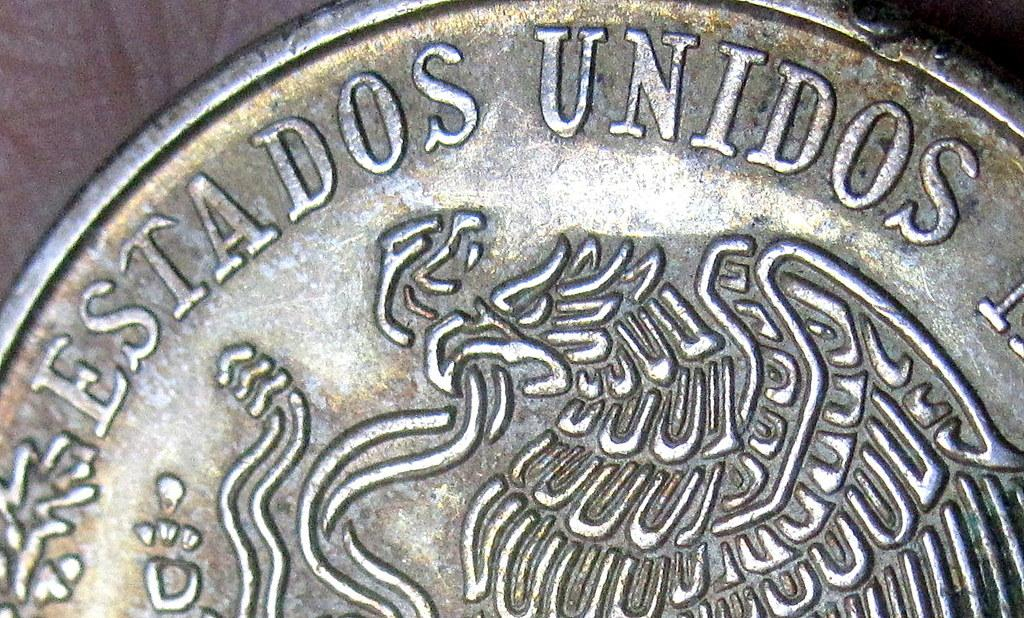<image>
Give a short and clear explanation of the subsequent image. coin with the words Estados Unidos printed on the side. 